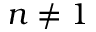<formula> <loc_0><loc_0><loc_500><loc_500>n \ne 1</formula> 